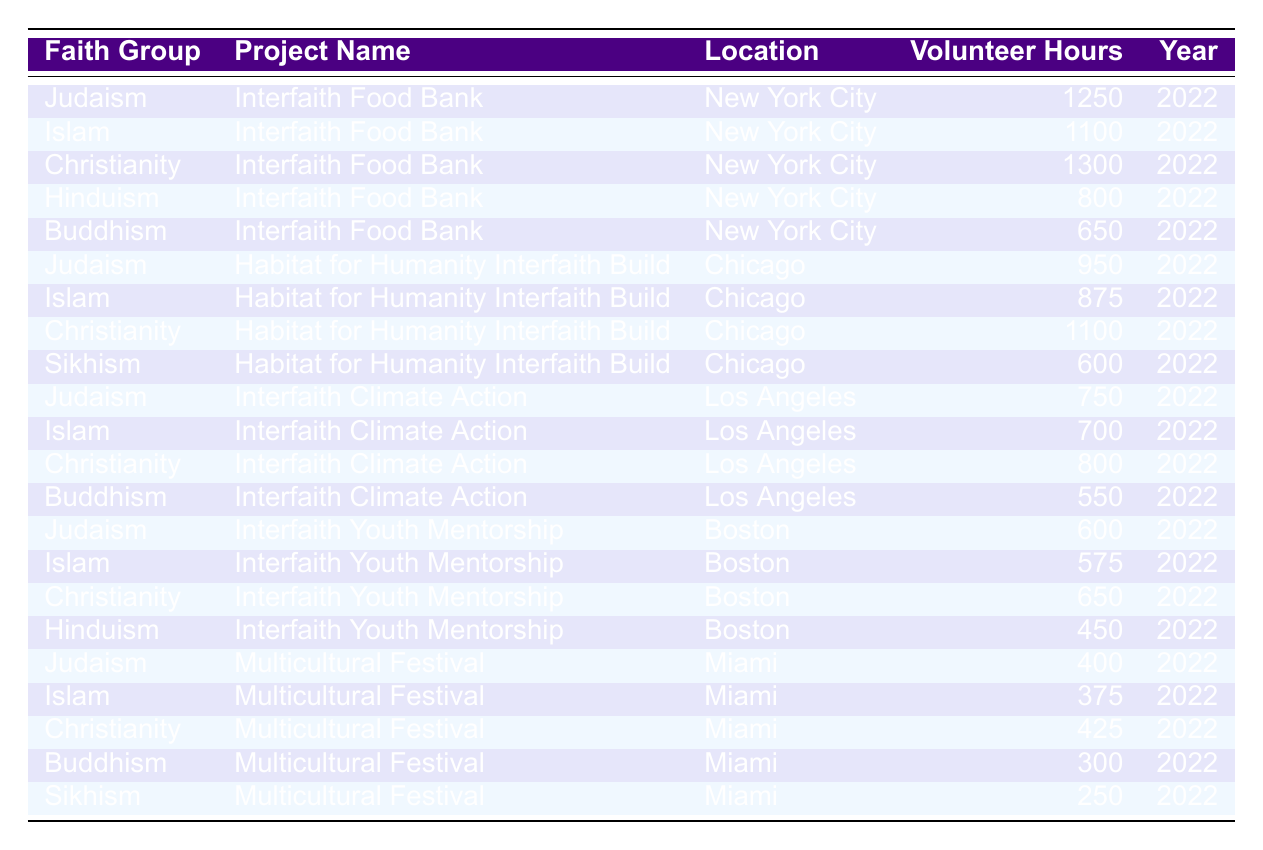What is the total number of volunteer hours contributed by Christianity? To find the total hours contributed by Christianity, I will look at each project associated with Christianity and sum their volunteer hours: 1300 (Interfaith Food Bank) + 1100 (Habitat for Humanity Interfaith Build) + 800 (Interfaith Climate Action) + 650 (Interfaith Youth Mentorship) + 425 (Multicultural Festival) = 4275
Answer: 4275 Which project received the highest total volunteer hours across all faith groups? To find the project with the highest total hours, I will sum the volunteer hours for each project: Interfaith Food Bank: 1250 (Judaism) + 1100 (Islam) + 1300 (Christianity) + 800 (Hinduism) + 650 (Buddhism) = 4100; Habitat for Humanity Interfaith Build: 950 (Judaism) + 875 (Islam) + 1100 (Christianity) + 600 (Sikhism) = 3525; Interfaith Climate Action: 750 (Judaism) + 700 (Islam) + 800 (Christianity) + 550 (Buddhism) = 2800; Interfaith Youth Mentorship: 600 (Judaism) + 575 (Islam) + 650 (Christianity) + 450 (Hinduism) = 2275; Multicultural Festival: 400 (Judaism) + 375 (Islam) + 425 (Christianity) + 300 (Buddhism) + 250 (Sikhism) = 1725. The highest is the Interfaith Food Bank with 4100 hours.
Answer: Interfaith Food Bank Did Buddhism contribute more volunteer hours to the Interfaith Food Bank or the Interfaith Climate Action? I will compare the volunteer hours contributed by Buddhism for both projects: 650 hours for the Interfaith Food Bank and 550 hours for the Interfaith Climate Action. Since 650 is greater than 550, Buddhism contributed more to the Interfaith Food Bank.
Answer: Yes, more to the Interfaith Food Bank What is the average number of volunteer hours contributed by Islam across all projects? The total hours for Islam are: 1100 (Interfaith Food Bank) + 875 (Habitat for Humanity Interfaith Build) + 700 (Interfaith Climate Action) + 575 (Interfaith Youth Mentorship) + 375 (Multicultural Festival) = 4025. There are 5 projects, so the average is 4025 / 5 = 805.
Answer: 805 How many volunteer hours did Judaism contribute in total across all projects, and how does it compare to the total volunteer hours of Hinduism? The total hours for Judaism are: 1250 (Interfaith Food Bank) + 950 (Habitat for Humanity Interfaith Build) + 750 (Interfaith Climate Action) + 600 (Interfaith Youth Mentorship) + 400 (Multicultural Festival) = 3950. For Hinduism, the total hours are 800 (Interfaith Food Bank) + 450 (Interfaith Youth Mentorship) = 1250. So, Judaism contributed more hours, specifically 3950 compared to 1250.
Answer: Judaism contributed more, 3950 vs 1250 Which faith group contributed the least volunteer hours overall? To determine the faith group with the least total hours, I will sum their contributions: Judaism (3950), Islam (4025), Christianity (4275), Hinduism (1250), Buddhism (1500), and Sikhism (850). The least is Sikhism with 850 hours.
Answer: Sikhism What percentage of the total volunteer hours contributed to the Interfaith Food Bank came from Christianity? First, the total hours for the Interfaith Food Bank is 4100. Christianity contributed 1300 hours, so the percentage is (1300 / 4100) * 100 = 31.71%.
Answer: 31.71% Was there any project where all participating faith groups contributed at least 500 volunteer hours? For each project, I will check if all faiths contributed at least 500 hours: Interfaith Food Bank - Yes, Habitat for Humanity Interfaith Build - No (Sikhism contributed 600 hours), Interfaith Climate Action - No (Buddhism contributed 550), Interfaith Youth Mentorship - No (Hinduism contributed 450), and Multicultural Festival - No (Sikhism contributed 250). Hence, only the Interfaith Food Bank meets the criteria.
Answer: Yes, Interfaith Food Bank 